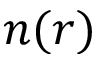Convert formula to latex. <formula><loc_0><loc_0><loc_500><loc_500>n ( r )</formula> 